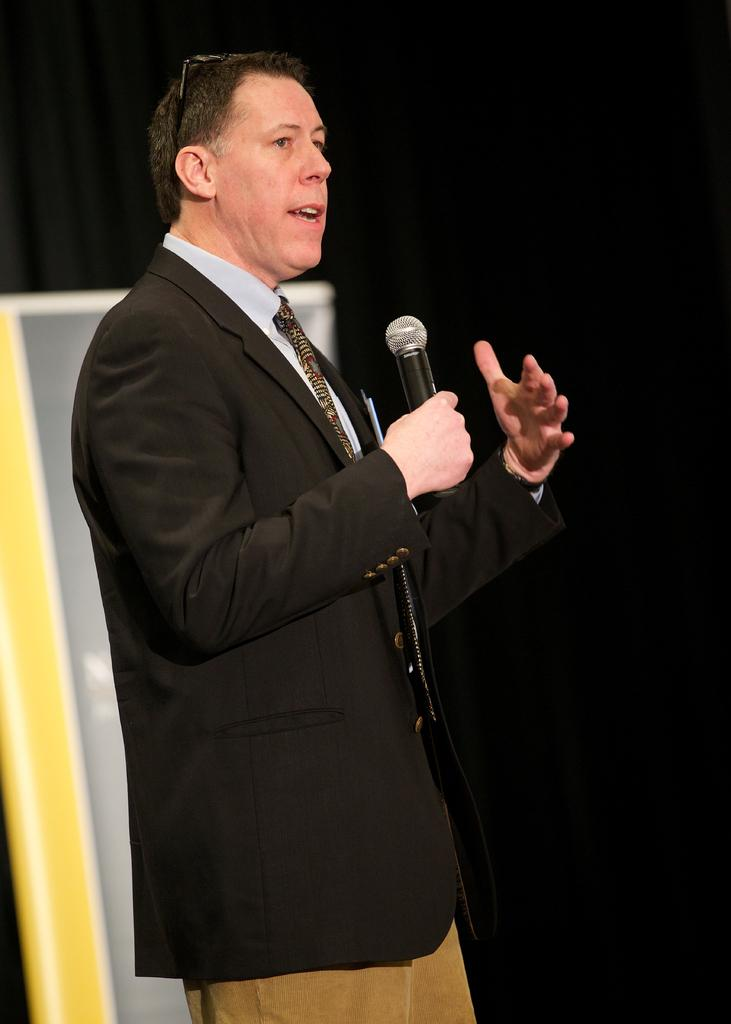What is the main subject of the image? There is a man standing in the center of the image. What is the man holding in the image? The man is holding a microphone. What can be seen in the background of the image? There is a wall and a wood stand in the background of the image. What time of day does the man appear to be feeling angry in the image? There is no indication of the man feeling angry or any specific time of day in the image. 